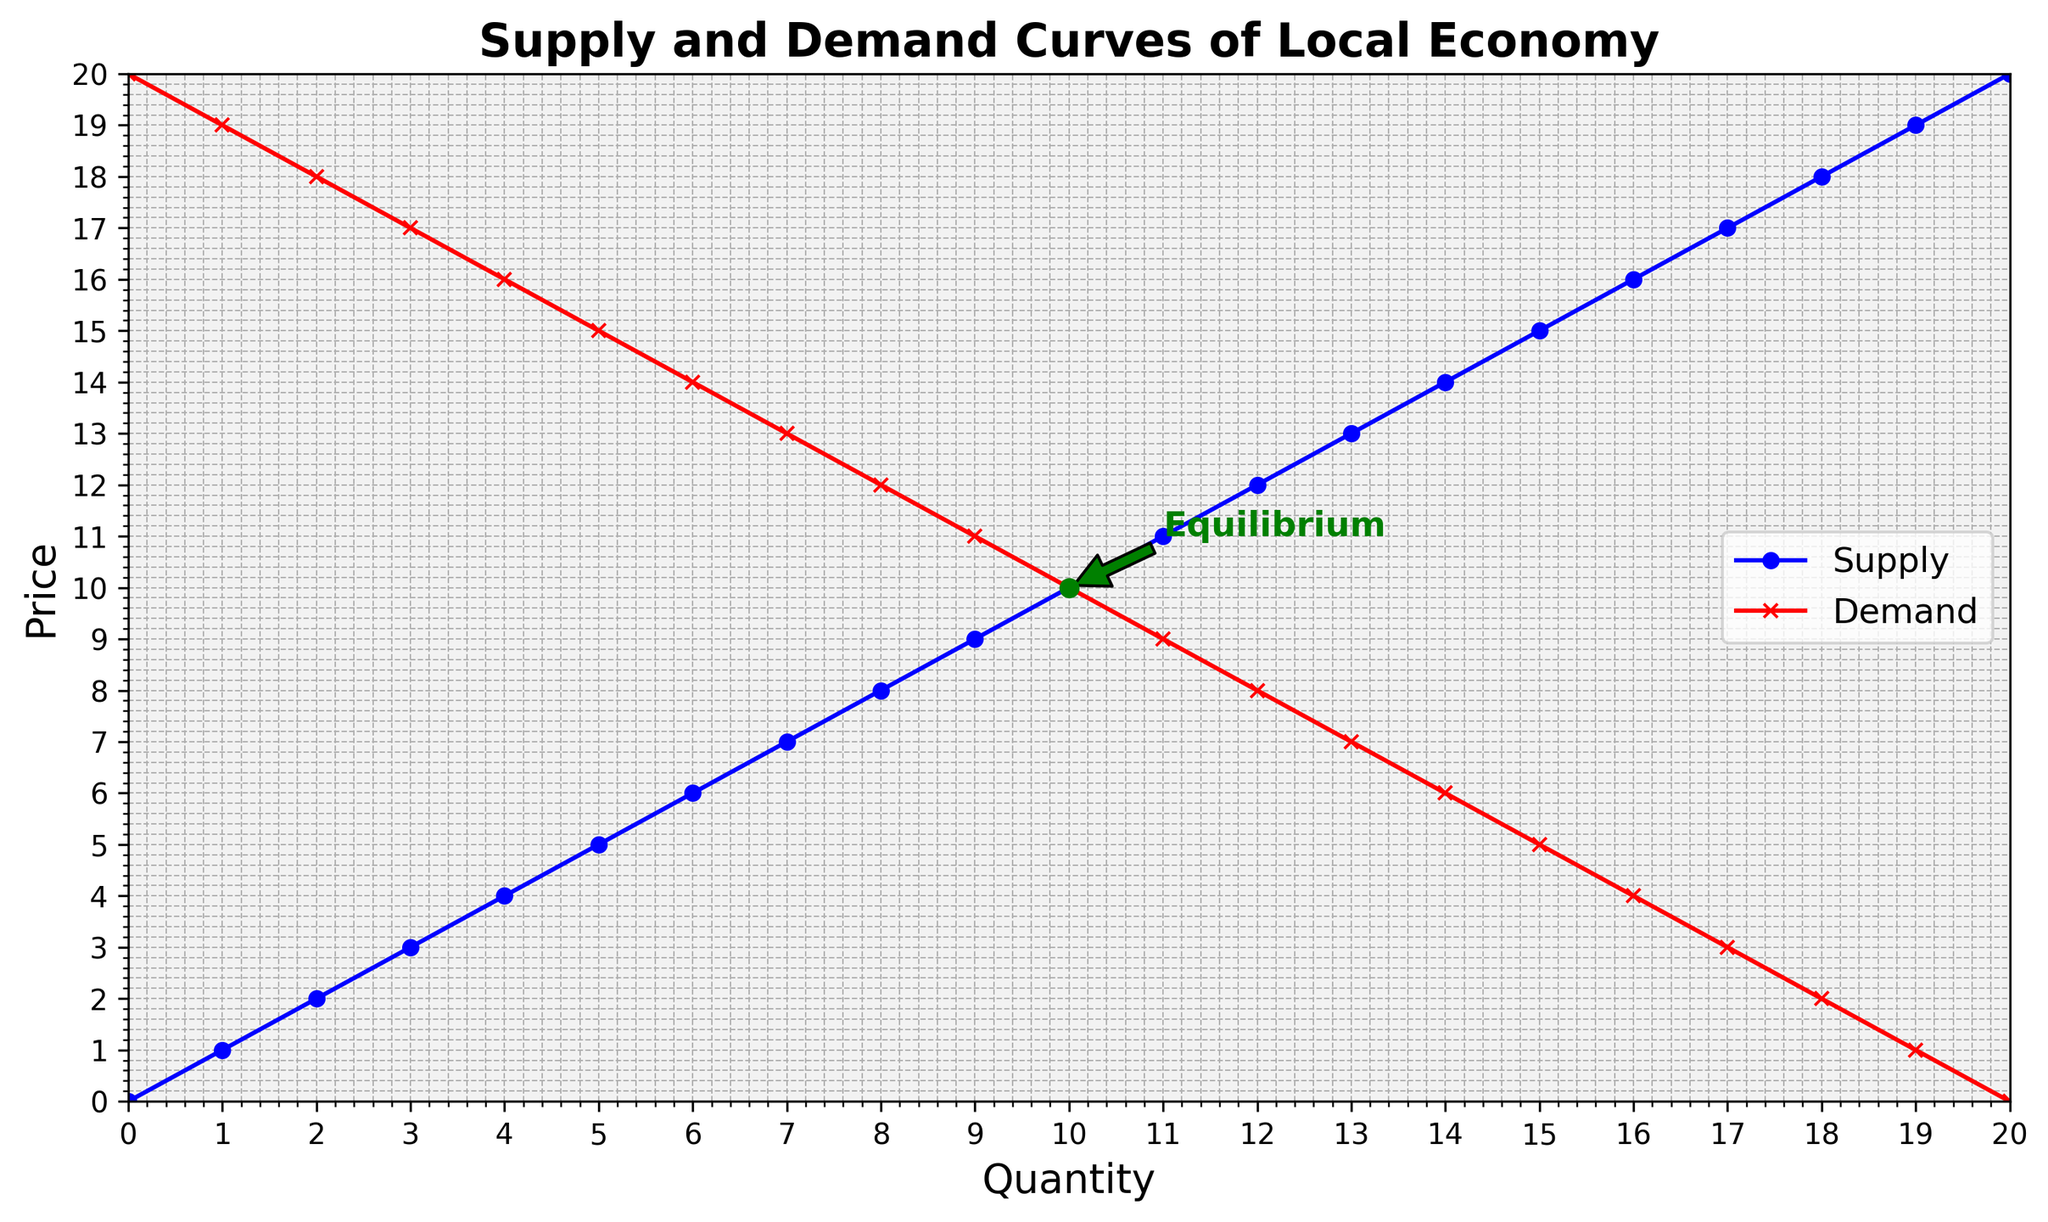When do the supply and demand curves intersect? The supply and demand curves intersect where they have the same Quantity and Price values. According to the data, this occurs at Quantity = 10 and Price = 10.
Answer: At Quantity = 10 and Price = 10 At which quantities is the difference between the supply and demand prices the greatest? The difference between the supply and demand prices is the greatest when the difference between the y-values of the supply and demand curves is the maximum. This occurs at the extremes, Quantity = 0 or Quantity = 20, with a difference of 20 (20 - 0).
Answer: At Quantity = 0 and Quantity = 20 What color represents the demand curve? The demand curve is represented by the red line with 'x' markers.
Answer: Red What is the equilibrium price and quantity? The equilibrium point is where the supply and demand curves intersect. This is annotated in green at Quantity = 10, Price = 10.
Answer: Price = 10, Quantity = 10 How much does the supply price change as quantity increases from 8 to 12? To find the change, observe the increase in the supply curve from Quantity = 8 to Quantity = 12. At Quantity = 8, the supply price is 8, and at Quantity = 12, it is 12. The change is 12 - 8 = 4.
Answer: 4 What is the visual difference between the supply and demand curves at Quantity = 5? The supply and demand curves can be differentiated by their color and markers. At Quantity = 5, the supply curve is a blue line with 'o' markers, and the demand curve is a red line with 'x' markers. Additionally, the supply price is 5 and demand price is 15.
Answer: Blue 'o' markers for supply and Red 'x' markers for demand At Quantity = 15, is the price higher for supply or demand? The supply price at Quantity = 15 is the y-value on the supply curve (15), and for the demand price, it is the y-value on the demand curve (5). Since 15 is greater than 5, the supply price is higher.
Answer: Supply At what quantity do the supply and demand curves have zero price? The supply curve has a zero price at Quantity = 0, and the demand curve has a zero price at Quantity = 20.
Answer: Supply at 0 and Demand at 20 What is the average price of supply and demand at Quantity = 7? At Quantity = 7, the supply price is 7, and the demand price is 13. The average price is calculated as (7 + 13) / 2 = 10.
Answer: 10 Does the supply curve have any minor ticks? Yes, the supply curve (and the entire plot) features minor ticks on the axes, as indicated by the grid settings.
Answer: Yes 